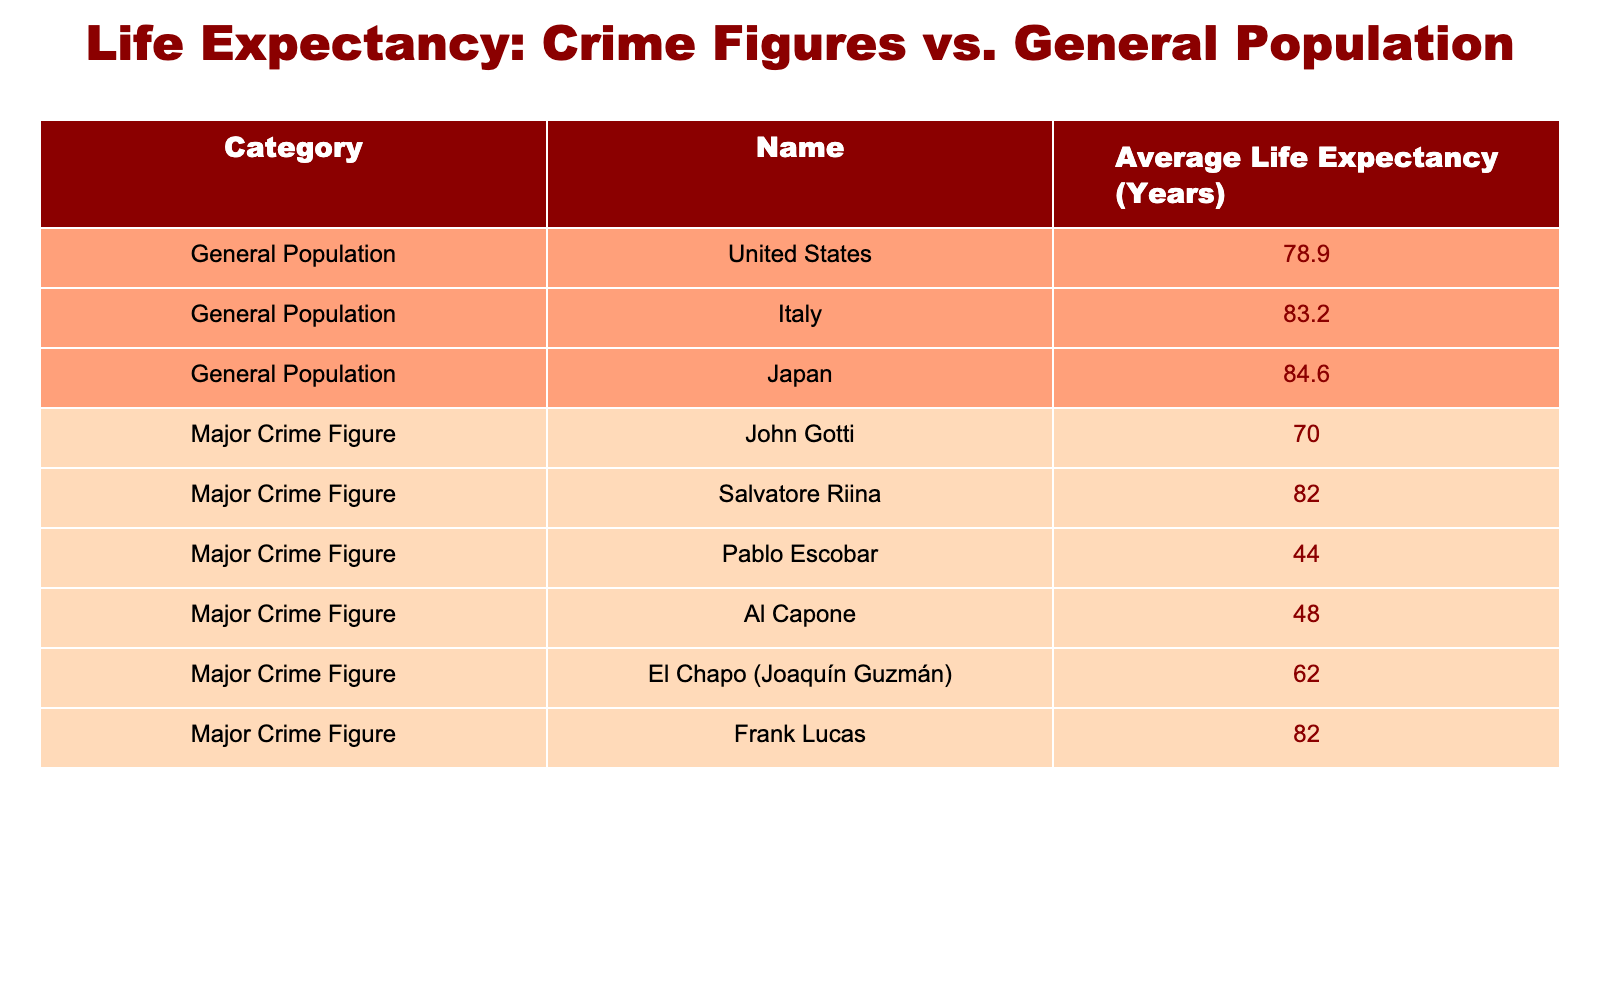What is the average life expectancy of the general population in the United States? According to the table, the average life expectancy for the general population in the United States is explicitly listed as 78.9 years.
Answer: 78.9 years Which crime figure has the lowest life expectancy according to the table? In the table, Pablo Escobar has the lowest average life expectancy at 44 years, which is mentioned in his specific entry under Major Crime Figures.
Answer: Pablo Escobar What is the difference between the average life expectancy of John Gotti and Salvatore Riina? John Gotti has an average life expectancy of 70 years, while Salvatore Riina has 82 years. The difference is calculated as 82 - 70 = 12 years.
Answer: 12 years True or False: Frank Lucas and Salvatore Riina have the same average life expectancy. From the table, Frank Lucas has an average life expectancy of 82 years, which matches with Salvatore Riina's 82 years. Therefore, the statement is true.
Answer: True What is the average life expectancy of Major Crime Figures? The average can be calculated by taking the sum of life expectancies for the Major Crime Figures: (70 + 82 + 44 + 48 + 62 + 82) = 388. There are 6 figures, so dividing gives 388 / 6 = 64.67 years, which can be rounded to 65 years.
Answer: 65 years How many years less does Al Capone live compared to the average life expectancy of the general population in Japan? The average life expectancy in Japan is 84.6 years, and Al Capone's is 48 years. The difference is 84.6 - 48 = 36.6 years, meaning Al Capone lives about 36.6 years less.
Answer: 36.6 years Which group has a higher average life expectancy, Major Crime Figures or the General Population? The general population's average is derived from the entries: (78.9 + 83.2 + 84.6) / 3 = 82.2 years. The Major Crime Figures' average was calculated previously as about 64.67 years. Since 82.2 is greater than 64.67, the general population has a higher average life expectancy.
Answer: General Population Who are the Major Crime Figures with an average life expectancy over 60 years? The table lists John Gotti (70 years), Salvatore Riina (82 years), El Chapo (62 years), and Frank Lucas (82 years) as the Major Crime Figures with life expectancies over 60 years. Counting these, there are 4 such figures.
Answer: 4 figures 